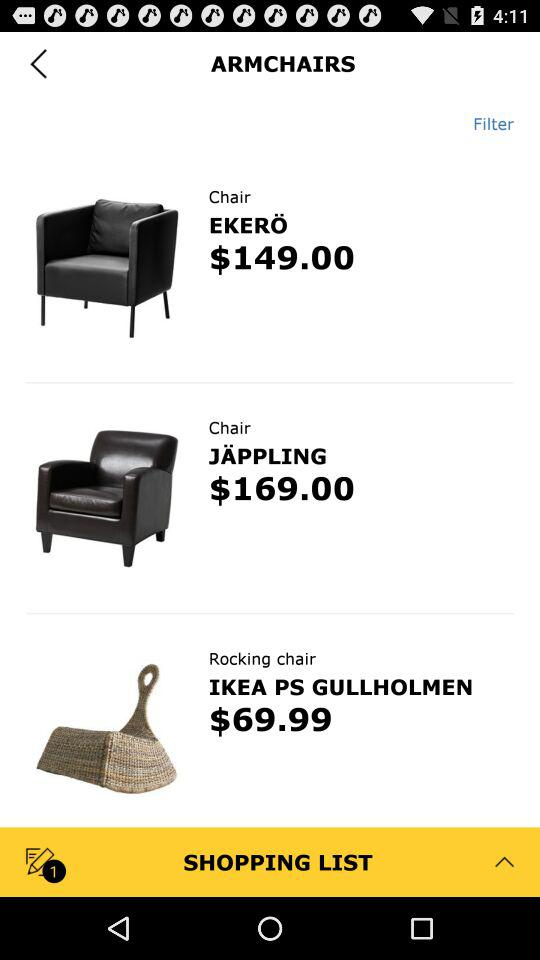How much more does the EKErö chair cost than the IKEA PS GULHOLMEN chair?
Answer the question using a single word or phrase. $79.01 